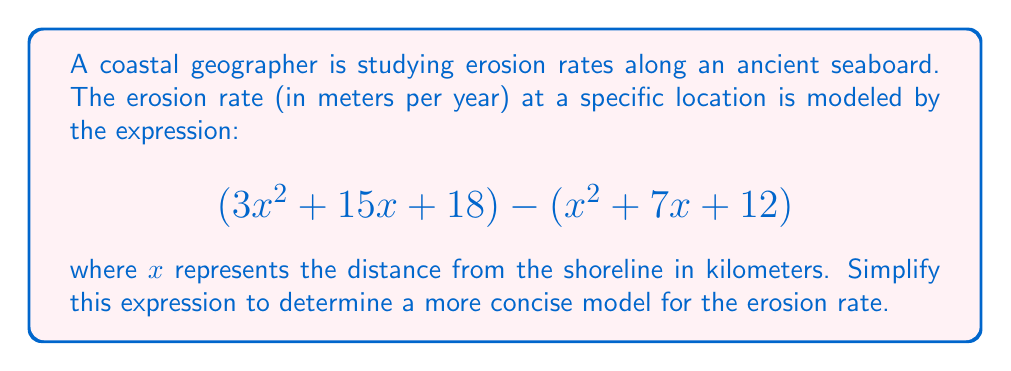Help me with this question. To simplify this expression, we need to subtract the second polynomial from the first. Let's approach this step-by-step:

1) First, let's identify the terms we're working with:
   $$(3x^2 + 15x + 18) - (x^2 + 7x + 12)$$

2) When subtracting polynomials, we subtract the corresponding terms. Remember that subtracting a positive term is the same as adding its negative:
   $$3x^2 + 15x + 18 - x^2 - 7x - 12$$

3) Now, let's rearrange the terms, grouping like terms together:
   $$(3x^2 - x^2) + (15x - 7x) + (18 - 12)$$

4) Simplify each group:
   - $3x^2 - x^2 = 2x^2$
   - $15x - 7x = 8x$
   - $18 - 12 = 6$

5) Combining these simplified terms:
   $$2x^2 + 8x + 6$$

This is our simplified expression for the erosion rate model.
Answer: $$2x^2 + 8x + 6$$ 